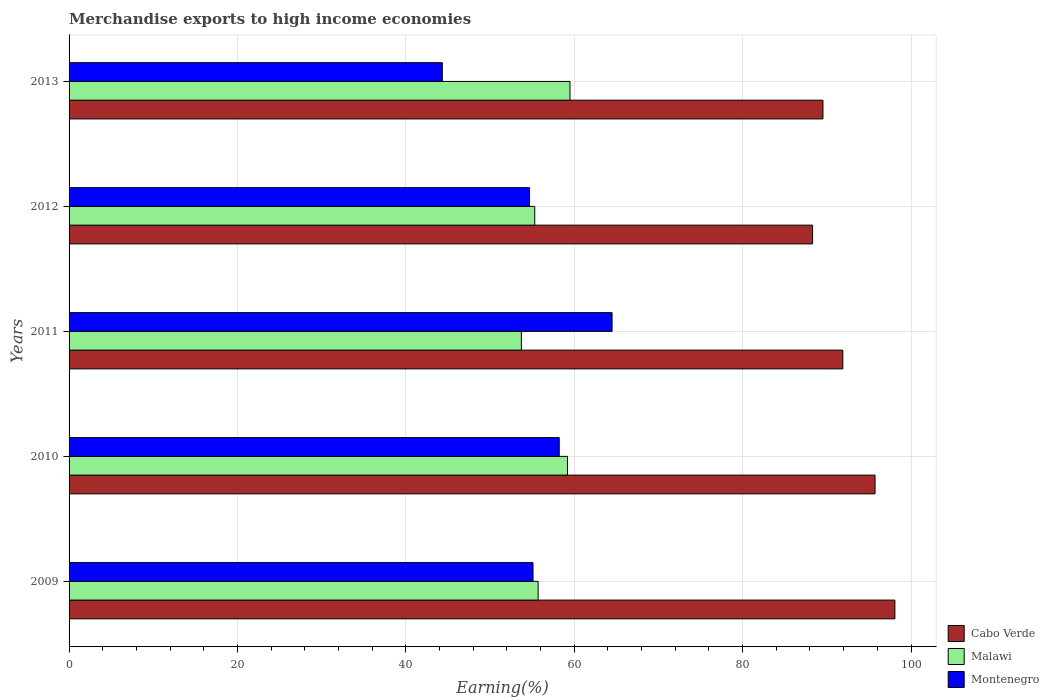How many groups of bars are there?
Your answer should be very brief. 5. Are the number of bars on each tick of the Y-axis equal?
Give a very brief answer. Yes. What is the percentage of amount earned from merchandise exports in Malawi in 2010?
Offer a terse response. 59.2. Across all years, what is the maximum percentage of amount earned from merchandise exports in Montenegro?
Give a very brief answer. 64.49. Across all years, what is the minimum percentage of amount earned from merchandise exports in Malawi?
Your answer should be compact. 53.72. In which year was the percentage of amount earned from merchandise exports in Malawi minimum?
Give a very brief answer. 2011. What is the total percentage of amount earned from merchandise exports in Montenegro in the graph?
Give a very brief answer. 276.84. What is the difference between the percentage of amount earned from merchandise exports in Malawi in 2010 and that in 2012?
Give a very brief answer. 3.89. What is the difference between the percentage of amount earned from merchandise exports in Malawi in 2011 and the percentage of amount earned from merchandise exports in Montenegro in 2013?
Provide a succinct answer. 9.39. What is the average percentage of amount earned from merchandise exports in Cabo Verde per year?
Provide a short and direct response. 92.71. In the year 2011, what is the difference between the percentage of amount earned from merchandise exports in Montenegro and percentage of amount earned from merchandise exports in Malawi?
Provide a succinct answer. 10.77. What is the ratio of the percentage of amount earned from merchandise exports in Cabo Verde in 2011 to that in 2013?
Provide a succinct answer. 1.03. Is the percentage of amount earned from merchandise exports in Montenegro in 2009 less than that in 2012?
Offer a terse response. No. Is the difference between the percentage of amount earned from merchandise exports in Montenegro in 2010 and 2011 greater than the difference between the percentage of amount earned from merchandise exports in Malawi in 2010 and 2011?
Ensure brevity in your answer.  No. What is the difference between the highest and the second highest percentage of amount earned from merchandise exports in Montenegro?
Offer a terse response. 6.28. What is the difference between the highest and the lowest percentage of amount earned from merchandise exports in Malawi?
Offer a very short reply. 5.77. In how many years, is the percentage of amount earned from merchandise exports in Cabo Verde greater than the average percentage of amount earned from merchandise exports in Cabo Verde taken over all years?
Provide a succinct answer. 2. Is the sum of the percentage of amount earned from merchandise exports in Malawi in 2010 and 2011 greater than the maximum percentage of amount earned from merchandise exports in Montenegro across all years?
Provide a short and direct response. Yes. What does the 1st bar from the top in 2009 represents?
Provide a short and direct response. Montenegro. What does the 1st bar from the bottom in 2009 represents?
Offer a terse response. Cabo Verde. Are all the bars in the graph horizontal?
Provide a succinct answer. Yes. What is the difference between two consecutive major ticks on the X-axis?
Your answer should be very brief. 20. Does the graph contain grids?
Give a very brief answer. Yes. How many legend labels are there?
Provide a short and direct response. 3. What is the title of the graph?
Keep it short and to the point. Merchandise exports to high income economies. Does "Germany" appear as one of the legend labels in the graph?
Offer a very short reply. No. What is the label or title of the X-axis?
Provide a succinct answer. Earning(%). What is the label or title of the Y-axis?
Your answer should be compact. Years. What is the Earning(%) in Cabo Verde in 2009?
Keep it short and to the point. 98.08. What is the Earning(%) in Malawi in 2009?
Provide a short and direct response. 55.71. What is the Earning(%) of Montenegro in 2009?
Your answer should be compact. 55.1. What is the Earning(%) in Cabo Verde in 2010?
Provide a short and direct response. 95.73. What is the Earning(%) in Malawi in 2010?
Offer a terse response. 59.2. What is the Earning(%) in Montenegro in 2010?
Provide a succinct answer. 58.22. What is the Earning(%) of Cabo Verde in 2011?
Give a very brief answer. 91.9. What is the Earning(%) of Malawi in 2011?
Provide a short and direct response. 53.72. What is the Earning(%) in Montenegro in 2011?
Provide a succinct answer. 64.49. What is the Earning(%) of Cabo Verde in 2012?
Offer a very short reply. 88.31. What is the Earning(%) in Malawi in 2012?
Ensure brevity in your answer.  55.31. What is the Earning(%) of Montenegro in 2012?
Provide a short and direct response. 54.69. What is the Earning(%) in Cabo Verde in 2013?
Ensure brevity in your answer.  89.54. What is the Earning(%) in Malawi in 2013?
Ensure brevity in your answer.  59.49. What is the Earning(%) of Montenegro in 2013?
Make the answer very short. 44.33. Across all years, what is the maximum Earning(%) of Cabo Verde?
Give a very brief answer. 98.08. Across all years, what is the maximum Earning(%) in Malawi?
Keep it short and to the point. 59.49. Across all years, what is the maximum Earning(%) of Montenegro?
Offer a very short reply. 64.49. Across all years, what is the minimum Earning(%) in Cabo Verde?
Your answer should be compact. 88.31. Across all years, what is the minimum Earning(%) of Malawi?
Offer a terse response. 53.72. Across all years, what is the minimum Earning(%) of Montenegro?
Provide a short and direct response. 44.33. What is the total Earning(%) in Cabo Verde in the graph?
Provide a short and direct response. 463.56. What is the total Earning(%) of Malawi in the graph?
Provide a short and direct response. 283.43. What is the total Earning(%) of Montenegro in the graph?
Provide a succinct answer. 276.84. What is the difference between the Earning(%) in Cabo Verde in 2009 and that in 2010?
Provide a succinct answer. 2.36. What is the difference between the Earning(%) in Malawi in 2009 and that in 2010?
Your answer should be compact. -3.49. What is the difference between the Earning(%) of Montenegro in 2009 and that in 2010?
Your answer should be compact. -3.12. What is the difference between the Earning(%) in Cabo Verde in 2009 and that in 2011?
Provide a succinct answer. 6.19. What is the difference between the Earning(%) of Malawi in 2009 and that in 2011?
Your answer should be very brief. 1.99. What is the difference between the Earning(%) in Montenegro in 2009 and that in 2011?
Offer a terse response. -9.39. What is the difference between the Earning(%) in Cabo Verde in 2009 and that in 2012?
Give a very brief answer. 9.78. What is the difference between the Earning(%) in Malawi in 2009 and that in 2012?
Provide a short and direct response. 0.4. What is the difference between the Earning(%) of Montenegro in 2009 and that in 2012?
Provide a short and direct response. 0.41. What is the difference between the Earning(%) in Cabo Verde in 2009 and that in 2013?
Give a very brief answer. 8.54. What is the difference between the Earning(%) of Malawi in 2009 and that in 2013?
Your answer should be very brief. -3.78. What is the difference between the Earning(%) in Montenegro in 2009 and that in 2013?
Keep it short and to the point. 10.77. What is the difference between the Earning(%) of Cabo Verde in 2010 and that in 2011?
Provide a short and direct response. 3.83. What is the difference between the Earning(%) of Malawi in 2010 and that in 2011?
Provide a short and direct response. 5.48. What is the difference between the Earning(%) in Montenegro in 2010 and that in 2011?
Your answer should be compact. -6.28. What is the difference between the Earning(%) in Cabo Verde in 2010 and that in 2012?
Provide a succinct answer. 7.42. What is the difference between the Earning(%) of Malawi in 2010 and that in 2012?
Provide a short and direct response. 3.89. What is the difference between the Earning(%) of Montenegro in 2010 and that in 2012?
Provide a short and direct response. 3.53. What is the difference between the Earning(%) in Cabo Verde in 2010 and that in 2013?
Give a very brief answer. 6.19. What is the difference between the Earning(%) in Malawi in 2010 and that in 2013?
Give a very brief answer. -0.3. What is the difference between the Earning(%) of Montenegro in 2010 and that in 2013?
Your response must be concise. 13.89. What is the difference between the Earning(%) of Cabo Verde in 2011 and that in 2012?
Offer a terse response. 3.59. What is the difference between the Earning(%) of Malawi in 2011 and that in 2012?
Make the answer very short. -1.59. What is the difference between the Earning(%) in Montenegro in 2011 and that in 2012?
Your response must be concise. 9.81. What is the difference between the Earning(%) in Cabo Verde in 2011 and that in 2013?
Offer a terse response. 2.36. What is the difference between the Earning(%) of Malawi in 2011 and that in 2013?
Your response must be concise. -5.77. What is the difference between the Earning(%) of Montenegro in 2011 and that in 2013?
Keep it short and to the point. 20.16. What is the difference between the Earning(%) of Cabo Verde in 2012 and that in 2013?
Provide a succinct answer. -1.23. What is the difference between the Earning(%) of Malawi in 2012 and that in 2013?
Make the answer very short. -4.19. What is the difference between the Earning(%) in Montenegro in 2012 and that in 2013?
Make the answer very short. 10.36. What is the difference between the Earning(%) in Cabo Verde in 2009 and the Earning(%) in Malawi in 2010?
Your response must be concise. 38.89. What is the difference between the Earning(%) in Cabo Verde in 2009 and the Earning(%) in Montenegro in 2010?
Your answer should be compact. 39.87. What is the difference between the Earning(%) of Malawi in 2009 and the Earning(%) of Montenegro in 2010?
Provide a succinct answer. -2.51. What is the difference between the Earning(%) of Cabo Verde in 2009 and the Earning(%) of Malawi in 2011?
Make the answer very short. 44.36. What is the difference between the Earning(%) in Cabo Verde in 2009 and the Earning(%) in Montenegro in 2011?
Ensure brevity in your answer.  33.59. What is the difference between the Earning(%) of Malawi in 2009 and the Earning(%) of Montenegro in 2011?
Your answer should be compact. -8.78. What is the difference between the Earning(%) in Cabo Verde in 2009 and the Earning(%) in Malawi in 2012?
Provide a short and direct response. 42.78. What is the difference between the Earning(%) of Cabo Verde in 2009 and the Earning(%) of Montenegro in 2012?
Your response must be concise. 43.39. What is the difference between the Earning(%) of Malawi in 2009 and the Earning(%) of Montenegro in 2012?
Give a very brief answer. 1.02. What is the difference between the Earning(%) of Cabo Verde in 2009 and the Earning(%) of Malawi in 2013?
Keep it short and to the point. 38.59. What is the difference between the Earning(%) in Cabo Verde in 2009 and the Earning(%) in Montenegro in 2013?
Give a very brief answer. 53.75. What is the difference between the Earning(%) in Malawi in 2009 and the Earning(%) in Montenegro in 2013?
Keep it short and to the point. 11.38. What is the difference between the Earning(%) in Cabo Verde in 2010 and the Earning(%) in Malawi in 2011?
Your answer should be very brief. 42.01. What is the difference between the Earning(%) in Cabo Verde in 2010 and the Earning(%) in Montenegro in 2011?
Give a very brief answer. 31.23. What is the difference between the Earning(%) in Malawi in 2010 and the Earning(%) in Montenegro in 2011?
Your response must be concise. -5.3. What is the difference between the Earning(%) in Cabo Verde in 2010 and the Earning(%) in Malawi in 2012?
Offer a very short reply. 40.42. What is the difference between the Earning(%) in Cabo Verde in 2010 and the Earning(%) in Montenegro in 2012?
Ensure brevity in your answer.  41.04. What is the difference between the Earning(%) of Malawi in 2010 and the Earning(%) of Montenegro in 2012?
Your answer should be compact. 4.51. What is the difference between the Earning(%) in Cabo Verde in 2010 and the Earning(%) in Malawi in 2013?
Offer a terse response. 36.23. What is the difference between the Earning(%) in Cabo Verde in 2010 and the Earning(%) in Montenegro in 2013?
Offer a terse response. 51.4. What is the difference between the Earning(%) in Malawi in 2010 and the Earning(%) in Montenegro in 2013?
Give a very brief answer. 14.87. What is the difference between the Earning(%) of Cabo Verde in 2011 and the Earning(%) of Malawi in 2012?
Offer a terse response. 36.59. What is the difference between the Earning(%) of Cabo Verde in 2011 and the Earning(%) of Montenegro in 2012?
Provide a short and direct response. 37.21. What is the difference between the Earning(%) of Malawi in 2011 and the Earning(%) of Montenegro in 2012?
Give a very brief answer. -0.97. What is the difference between the Earning(%) in Cabo Verde in 2011 and the Earning(%) in Malawi in 2013?
Offer a very short reply. 32.4. What is the difference between the Earning(%) in Cabo Verde in 2011 and the Earning(%) in Montenegro in 2013?
Give a very brief answer. 47.57. What is the difference between the Earning(%) of Malawi in 2011 and the Earning(%) of Montenegro in 2013?
Your answer should be compact. 9.39. What is the difference between the Earning(%) in Cabo Verde in 2012 and the Earning(%) in Malawi in 2013?
Offer a very short reply. 28.81. What is the difference between the Earning(%) in Cabo Verde in 2012 and the Earning(%) in Montenegro in 2013?
Give a very brief answer. 43.98. What is the difference between the Earning(%) of Malawi in 2012 and the Earning(%) of Montenegro in 2013?
Make the answer very short. 10.98. What is the average Earning(%) of Cabo Verde per year?
Offer a terse response. 92.71. What is the average Earning(%) in Malawi per year?
Ensure brevity in your answer.  56.69. What is the average Earning(%) of Montenegro per year?
Keep it short and to the point. 55.37. In the year 2009, what is the difference between the Earning(%) of Cabo Verde and Earning(%) of Malawi?
Offer a very short reply. 42.37. In the year 2009, what is the difference between the Earning(%) in Cabo Verde and Earning(%) in Montenegro?
Ensure brevity in your answer.  42.98. In the year 2009, what is the difference between the Earning(%) of Malawi and Earning(%) of Montenegro?
Make the answer very short. 0.61. In the year 2010, what is the difference between the Earning(%) of Cabo Verde and Earning(%) of Malawi?
Your answer should be compact. 36.53. In the year 2010, what is the difference between the Earning(%) of Cabo Verde and Earning(%) of Montenegro?
Keep it short and to the point. 37.51. In the year 2010, what is the difference between the Earning(%) in Malawi and Earning(%) in Montenegro?
Keep it short and to the point. 0.98. In the year 2011, what is the difference between the Earning(%) of Cabo Verde and Earning(%) of Malawi?
Keep it short and to the point. 38.18. In the year 2011, what is the difference between the Earning(%) in Cabo Verde and Earning(%) in Montenegro?
Provide a succinct answer. 27.4. In the year 2011, what is the difference between the Earning(%) of Malawi and Earning(%) of Montenegro?
Your answer should be very brief. -10.77. In the year 2012, what is the difference between the Earning(%) of Cabo Verde and Earning(%) of Malawi?
Give a very brief answer. 33. In the year 2012, what is the difference between the Earning(%) of Cabo Verde and Earning(%) of Montenegro?
Provide a short and direct response. 33.62. In the year 2012, what is the difference between the Earning(%) of Malawi and Earning(%) of Montenegro?
Ensure brevity in your answer.  0.62. In the year 2013, what is the difference between the Earning(%) in Cabo Verde and Earning(%) in Malawi?
Give a very brief answer. 30.05. In the year 2013, what is the difference between the Earning(%) of Cabo Verde and Earning(%) of Montenegro?
Offer a very short reply. 45.21. In the year 2013, what is the difference between the Earning(%) in Malawi and Earning(%) in Montenegro?
Your answer should be very brief. 15.16. What is the ratio of the Earning(%) in Cabo Verde in 2009 to that in 2010?
Provide a succinct answer. 1.02. What is the ratio of the Earning(%) in Malawi in 2009 to that in 2010?
Offer a terse response. 0.94. What is the ratio of the Earning(%) in Montenegro in 2009 to that in 2010?
Offer a very short reply. 0.95. What is the ratio of the Earning(%) of Cabo Verde in 2009 to that in 2011?
Ensure brevity in your answer.  1.07. What is the ratio of the Earning(%) in Malawi in 2009 to that in 2011?
Offer a very short reply. 1.04. What is the ratio of the Earning(%) in Montenegro in 2009 to that in 2011?
Provide a short and direct response. 0.85. What is the ratio of the Earning(%) in Cabo Verde in 2009 to that in 2012?
Provide a succinct answer. 1.11. What is the ratio of the Earning(%) of Malawi in 2009 to that in 2012?
Ensure brevity in your answer.  1.01. What is the ratio of the Earning(%) in Montenegro in 2009 to that in 2012?
Provide a short and direct response. 1.01. What is the ratio of the Earning(%) in Cabo Verde in 2009 to that in 2013?
Make the answer very short. 1.1. What is the ratio of the Earning(%) in Malawi in 2009 to that in 2013?
Your answer should be very brief. 0.94. What is the ratio of the Earning(%) in Montenegro in 2009 to that in 2013?
Your answer should be very brief. 1.24. What is the ratio of the Earning(%) of Cabo Verde in 2010 to that in 2011?
Give a very brief answer. 1.04. What is the ratio of the Earning(%) of Malawi in 2010 to that in 2011?
Provide a short and direct response. 1.1. What is the ratio of the Earning(%) of Montenegro in 2010 to that in 2011?
Make the answer very short. 0.9. What is the ratio of the Earning(%) in Cabo Verde in 2010 to that in 2012?
Your response must be concise. 1.08. What is the ratio of the Earning(%) of Malawi in 2010 to that in 2012?
Make the answer very short. 1.07. What is the ratio of the Earning(%) in Montenegro in 2010 to that in 2012?
Ensure brevity in your answer.  1.06. What is the ratio of the Earning(%) of Cabo Verde in 2010 to that in 2013?
Your answer should be very brief. 1.07. What is the ratio of the Earning(%) of Malawi in 2010 to that in 2013?
Offer a terse response. 0.99. What is the ratio of the Earning(%) in Montenegro in 2010 to that in 2013?
Keep it short and to the point. 1.31. What is the ratio of the Earning(%) of Cabo Verde in 2011 to that in 2012?
Keep it short and to the point. 1.04. What is the ratio of the Earning(%) in Malawi in 2011 to that in 2012?
Provide a succinct answer. 0.97. What is the ratio of the Earning(%) of Montenegro in 2011 to that in 2012?
Make the answer very short. 1.18. What is the ratio of the Earning(%) of Cabo Verde in 2011 to that in 2013?
Your answer should be very brief. 1.03. What is the ratio of the Earning(%) in Malawi in 2011 to that in 2013?
Provide a succinct answer. 0.9. What is the ratio of the Earning(%) of Montenegro in 2011 to that in 2013?
Offer a very short reply. 1.45. What is the ratio of the Earning(%) in Cabo Verde in 2012 to that in 2013?
Give a very brief answer. 0.99. What is the ratio of the Earning(%) of Malawi in 2012 to that in 2013?
Provide a succinct answer. 0.93. What is the ratio of the Earning(%) of Montenegro in 2012 to that in 2013?
Provide a short and direct response. 1.23. What is the difference between the highest and the second highest Earning(%) in Cabo Verde?
Your answer should be compact. 2.36. What is the difference between the highest and the second highest Earning(%) of Malawi?
Offer a very short reply. 0.3. What is the difference between the highest and the second highest Earning(%) of Montenegro?
Your response must be concise. 6.28. What is the difference between the highest and the lowest Earning(%) of Cabo Verde?
Provide a succinct answer. 9.78. What is the difference between the highest and the lowest Earning(%) of Malawi?
Make the answer very short. 5.77. What is the difference between the highest and the lowest Earning(%) of Montenegro?
Your answer should be compact. 20.16. 